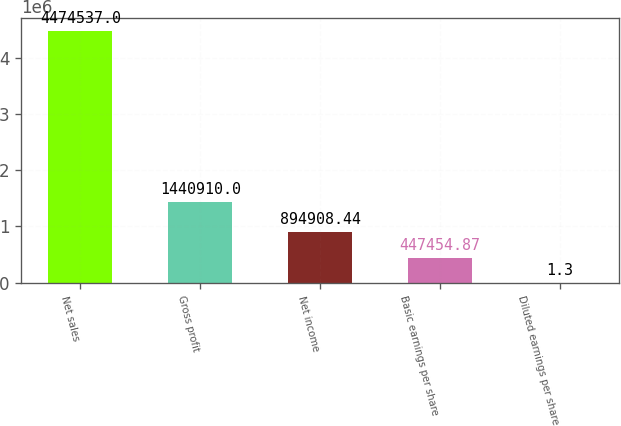Convert chart to OTSL. <chart><loc_0><loc_0><loc_500><loc_500><bar_chart><fcel>Net sales<fcel>Gross profit<fcel>Net income<fcel>Basic earnings per share<fcel>Diluted earnings per share<nl><fcel>4.47454e+06<fcel>1.44091e+06<fcel>894908<fcel>447455<fcel>1.3<nl></chart> 